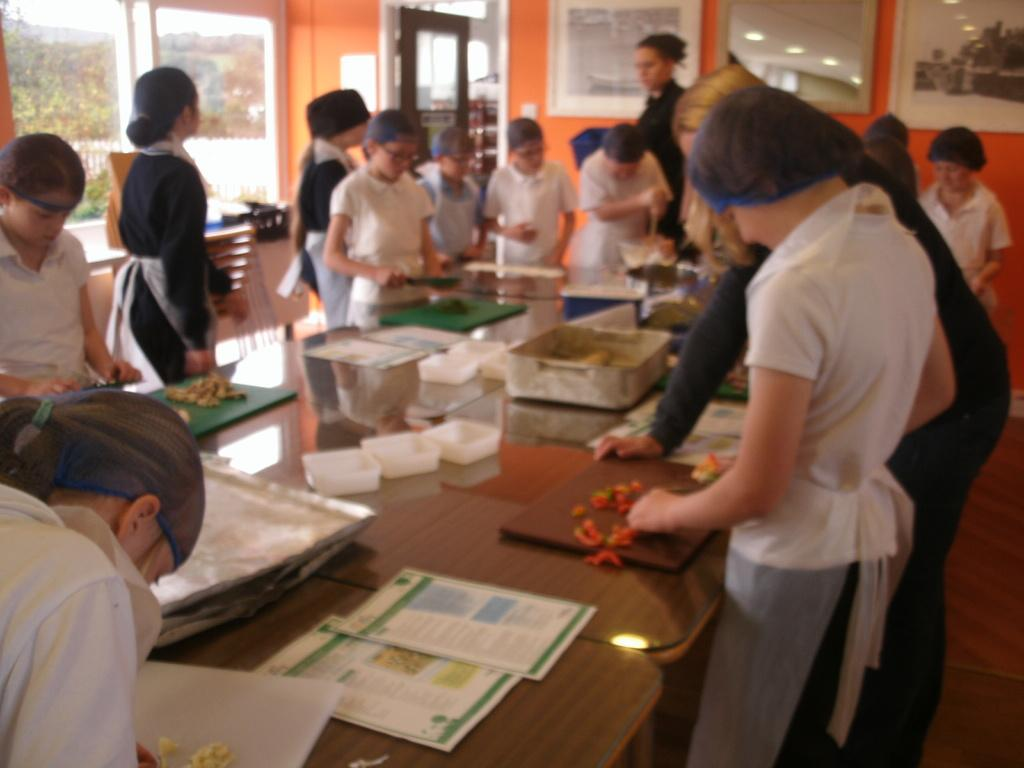What is happening in the image? There are people near a table in the image. What can be seen on the table? There are multiple objects on the table. What is visible in the background of the image? There is a window and a wall in the background of the image. What is hanging on the wall in the background of the image? There are frames on the wall in the background of the image. What type of collar is the aunt wearing in the image? There is no aunt present in the image, and therefore no collar to describe. What type of linen is draped over the table in the image? There is no linen draped over the table in the image; the table has multiple objects on it. 